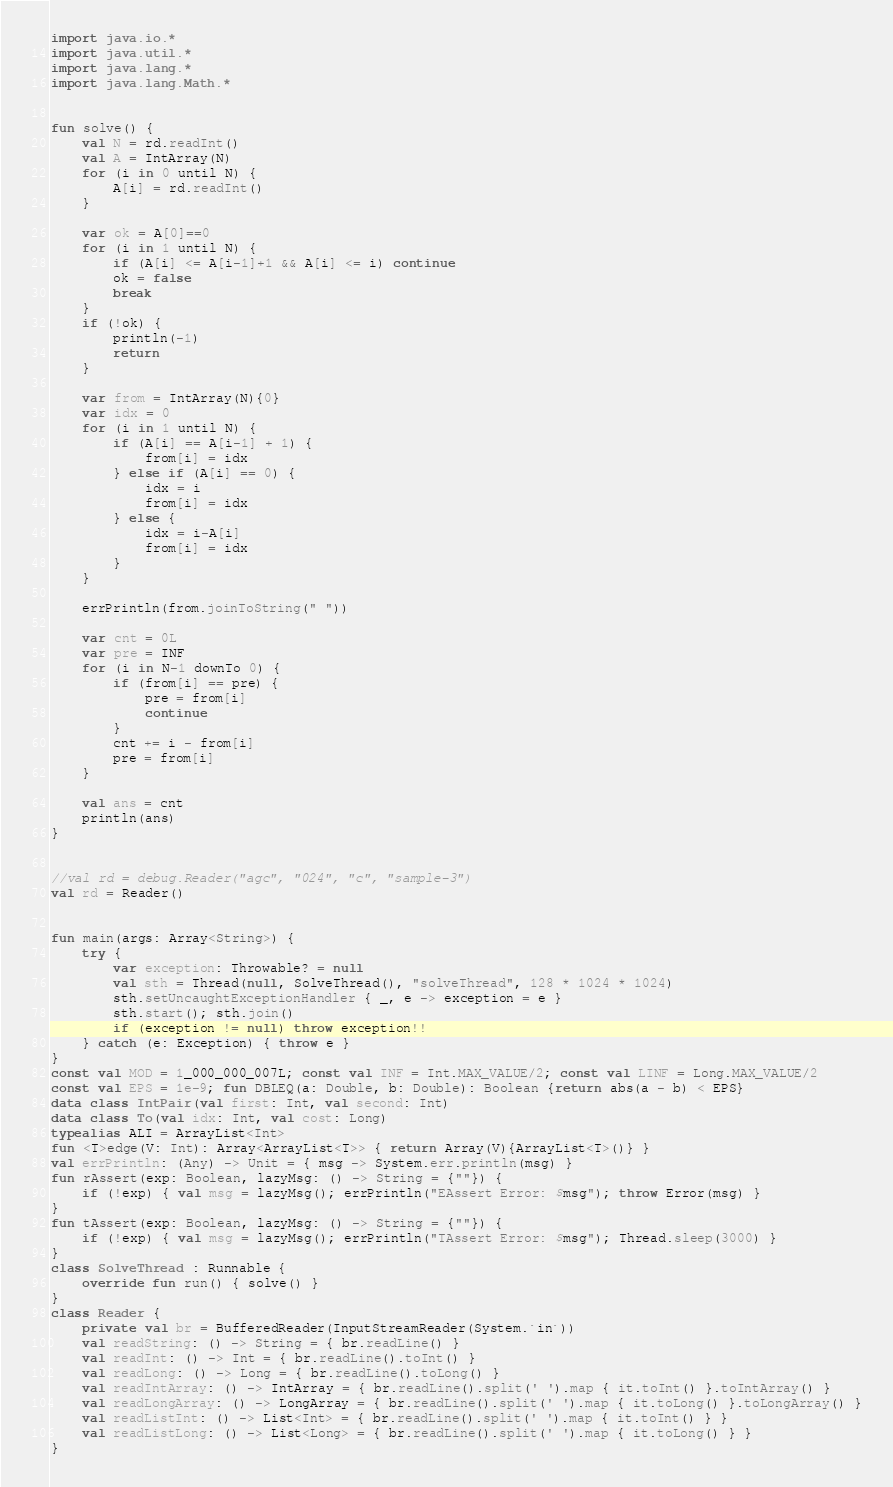<code> <loc_0><loc_0><loc_500><loc_500><_Kotlin_>import java.io.*
import java.util.*
import java.lang.*
import java.lang.Math.*


fun solve() {
    val N = rd.readInt()
    val A = IntArray(N)
    for (i in 0 until N) {
        A[i] = rd.readInt()
    }

    var ok = A[0]==0
    for (i in 1 until N) {
        if (A[i] <= A[i-1]+1 && A[i] <= i) continue
        ok = false
        break
    }
    if (!ok) {
        println(-1)
        return
    }

    var from = IntArray(N){0}
    var idx = 0
    for (i in 1 until N) {
        if (A[i] == A[i-1] + 1) {
            from[i] = idx
        } else if (A[i] == 0) {
            idx = i
            from[i] = idx
        } else {
            idx = i-A[i]
            from[i] = idx
        }
    }

    errPrintln(from.joinToString(" "))

    var cnt = 0L
    var pre = INF
    for (i in N-1 downTo 0) {
        if (from[i] == pre) {
            pre = from[i]
            continue
        }
        cnt += i - from[i]
        pre = from[i]
    }

    val ans = cnt
    println(ans)
}


//val rd = debug.Reader("agc", "024", "c", "sample-3")
val rd = Reader()


fun main(args: Array<String>) {
    try {
        var exception: Throwable? = null
        val sth = Thread(null, SolveThread(), "solveThread", 128 * 1024 * 1024)
        sth.setUncaughtExceptionHandler { _, e -> exception = e }
        sth.start(); sth.join()
        if (exception != null) throw exception!!
    } catch (e: Exception) { throw e }
}
const val MOD = 1_000_000_007L; const val INF = Int.MAX_VALUE/2; const val LINF = Long.MAX_VALUE/2
const val EPS = 1e-9; fun DBLEQ(a: Double, b: Double): Boolean {return abs(a - b) < EPS}
data class IntPair(val first: Int, val second: Int)
data class To(val idx: Int, val cost: Long)
typealias ALI = ArrayList<Int>
fun <T>edge(V: Int): Array<ArrayList<T>> { return Array(V){ArrayList<T>()} }
val errPrintln: (Any) -> Unit = { msg -> System.err.println(msg) }
fun rAssert(exp: Boolean, lazyMsg: () -> String = {""}) {
    if (!exp) { val msg = lazyMsg(); errPrintln("EAssert Error: $msg"); throw Error(msg) }
}
fun tAssert(exp: Boolean, lazyMsg: () -> String = {""}) {
    if (!exp) { val msg = lazyMsg(); errPrintln("TAssert Error: $msg"); Thread.sleep(3000) }
}
class SolveThread : Runnable {
    override fun run() { solve() }
}
class Reader {
    private val br = BufferedReader(InputStreamReader(System.`in`))
    val readString: () -> String = { br.readLine() }
    val readInt: () -> Int = { br.readLine().toInt() }
    val readLong: () -> Long = { br.readLine().toLong() }
    val readIntArray: () -> IntArray = { br.readLine().split(' ').map { it.toInt() }.toIntArray() }
    val readLongArray: () -> LongArray = { br.readLine().split(' ').map { it.toLong() }.toLongArray() }
    val readListInt: () -> List<Int> = { br.readLine().split(' ').map { it.toInt() } }
    val readListLong: () -> List<Long> = { br.readLine().split(' ').map { it.toLong() } }
}
</code> 